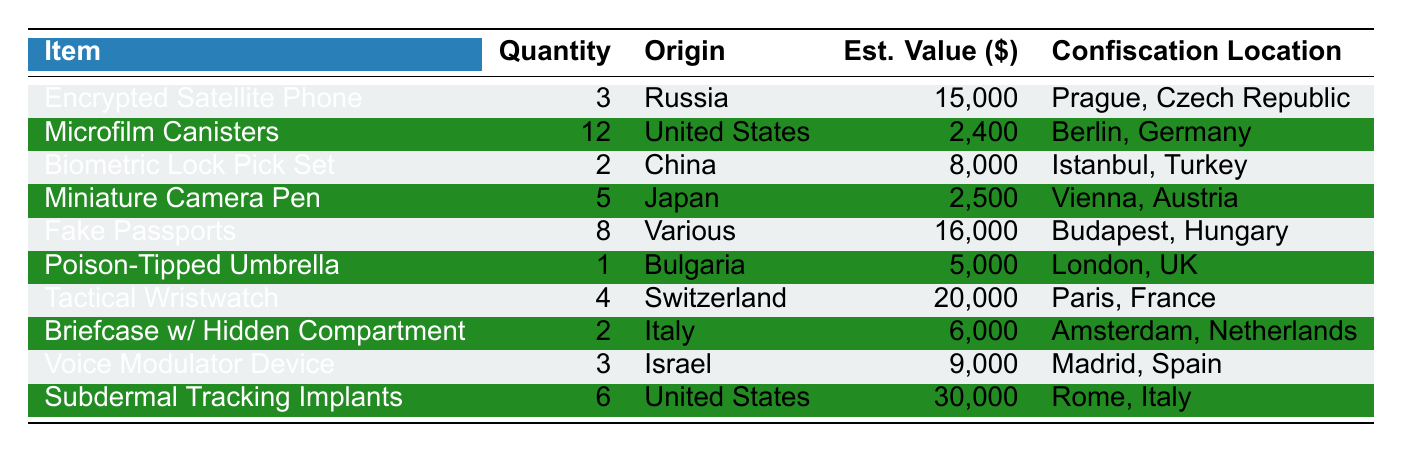What is the most valuable item on the list? The table indicates that the "Subdermal Tracking Implants" have the highest estimated value at $30,000.
Answer: Subdermal Tracking Implants How many items were confiscated from the United States? By counting the entries in the table, there are three items with "United States" as their origin: Microfilm Canisters, Subdermal Tracking Implants, and another entry for the same country.
Answer: 3 What is the total estimated value of all confiscated items? Adding the estimated values gives: 15000 + 2400 + 8000 + 2500 + 16000 + 5000 + 20000 + 6000 + 9000 + 30000 = 118900.
Answer: 118900 Are there any items with a quantity of 1? The "Poison-Tipped Umbrella" has a quantity of 1, verifying the presence of an item with that quantity.
Answer: Yes Which country has the highest number of confiscated items? Three items originated from the United States, more than any other country listed, making it the country with the highest number of items.
Answer: United States What is the average estimated value of items coming from Russia? There is only one item from Russia, the "Encrypted Satellite Phone", valued at $15,000, so the average is also $15,000.
Answer: 15000 Which location had the highest estimated value of confiscated items? Summing the estimated values of items confiscated at various locations reveals that "Rome, Italy" with $30,000 has the single highest value, making it the top location.
Answer: Rome, Italy How many more Microfilm Canisters than Poison-Tipped Umbrellas were confiscated? There were 12 Microfilm Canisters and only 1 Poison-Tipped Umbrella. The difference is 12 - 1 = 11.
Answer: 11 What are the origins of items confiscated in Budapest? The only item confiscated in Budapest is "Fake Passports," which originate from various places.
Answer: Various How many items were confiscated in Paris, France, and what was their total value? In Paris, 4 Tactical Wristwatches were confiscated, and their total estimated value is $20,000, which includes only this item.
Answer: 20000 